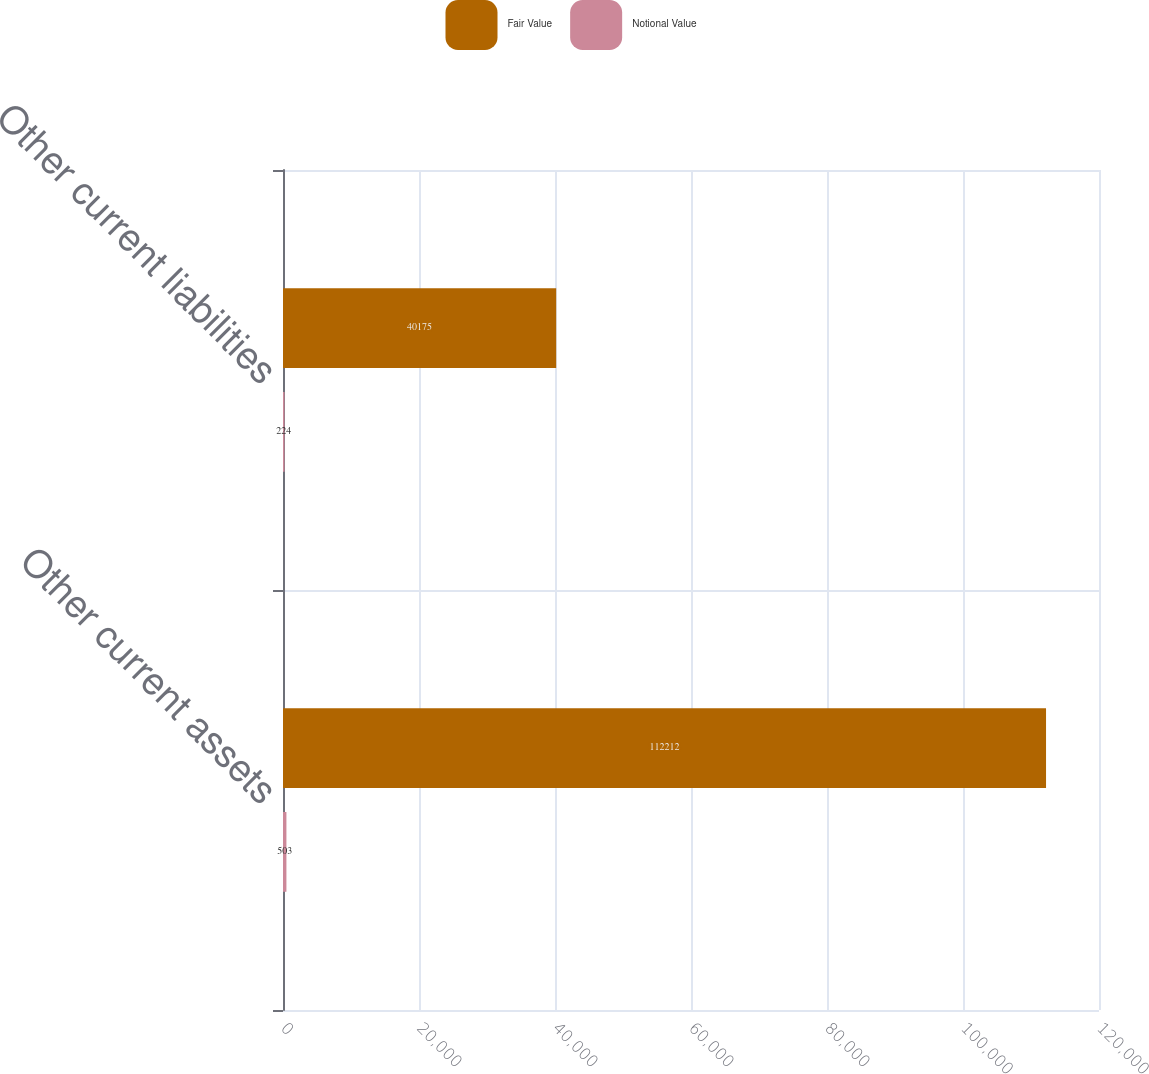Convert chart. <chart><loc_0><loc_0><loc_500><loc_500><stacked_bar_chart><ecel><fcel>Other current assets<fcel>Other current liabilities<nl><fcel>Fair Value<fcel>112212<fcel>40175<nl><fcel>Notional Value<fcel>503<fcel>224<nl></chart> 